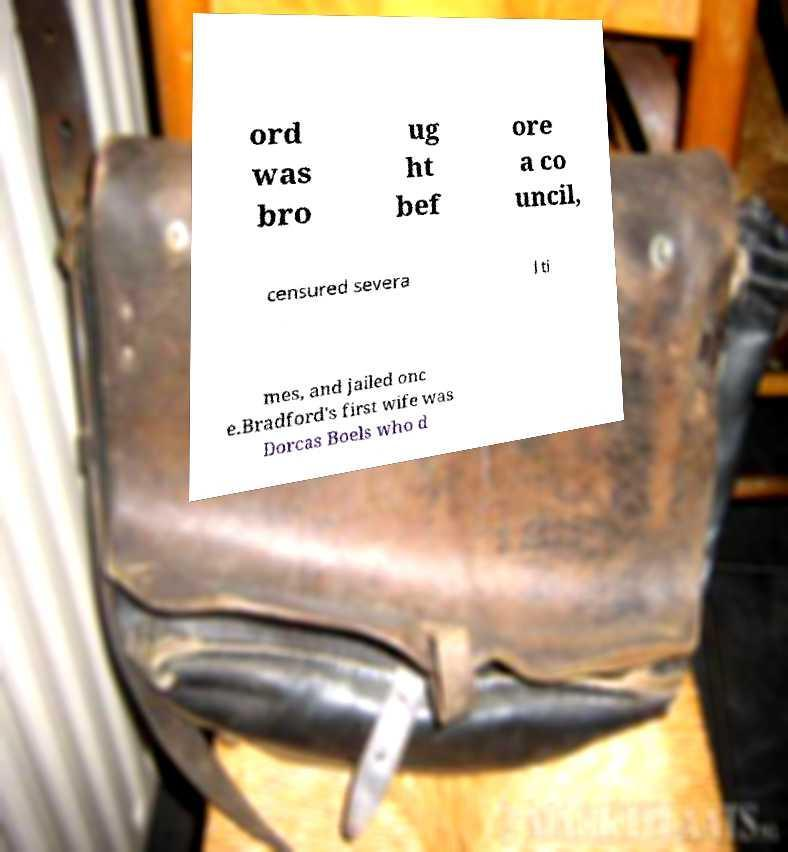Can you accurately transcribe the text from the provided image for me? ord was bro ug ht bef ore a co uncil, censured severa l ti mes, and jailed onc e.Bradford's first wife was Dorcas Boels who d 